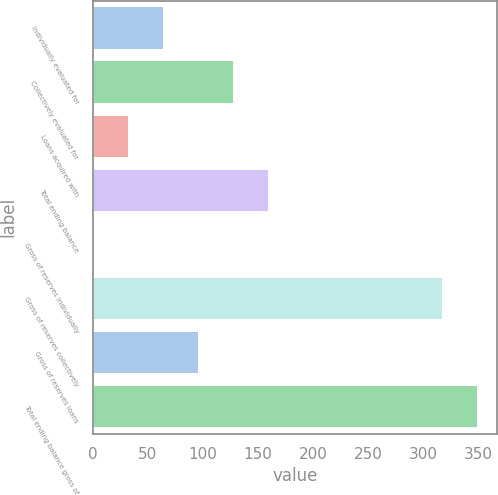<chart> <loc_0><loc_0><loc_500><loc_500><bar_chart><fcel>Individually evaluated for<fcel>Collectively evaluated for<fcel>Loans acquired with<fcel>Total ending balance<fcel>Gross of reserves individually<fcel>Gross of reserves collectively<fcel>Gross of reserves loans<fcel>Total ending balance gross of<nl><fcel>64.6<fcel>128.2<fcel>32.8<fcel>160<fcel>1<fcel>318<fcel>96.4<fcel>349.8<nl></chart> 